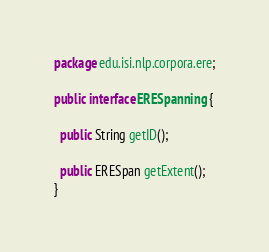Convert code to text. <code><loc_0><loc_0><loc_500><loc_500><_Java_>package edu.isi.nlp.corpora.ere;

public interface ERESpanning {

  public String getID();

  public ERESpan getExtent();
}
</code> 